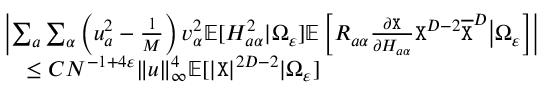Convert formula to latex. <formula><loc_0><loc_0><loc_500><loc_500>\begin{array} { r l } & { \left | \sum _ { a } \sum _ { \alpha } \left ( u _ { a } ^ { 2 } - \frac { 1 } M } \right ) v _ { \alpha } ^ { 2 } \mathbb { E } [ H _ { a \alpha } ^ { 2 } | \Omega _ { \varepsilon } ] \mathbb { E } \left [ R _ { a \alpha } \frac { \partial { X } } { \partial H _ { a \alpha } } { X } ^ { D - 2 } \overline { X } ^ { D } \Big | \Omega _ { \varepsilon } \right ] \right | } \\ & { \leq C N ^ { - 1 + 4 \varepsilon } \| { \boldsymbol u } \| _ { \infty } ^ { 4 } \mathbb { E } [ | { X } | ^ { 2 D - 2 } | \Omega _ { \varepsilon } ] } \end{array}</formula> 